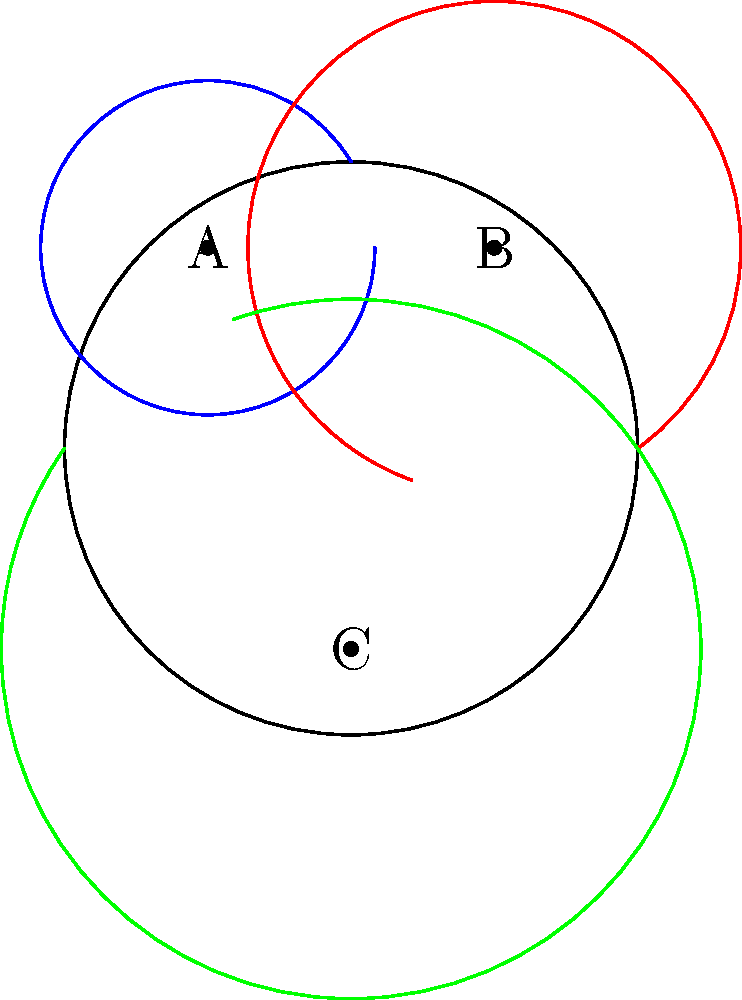On a non-Euclidean map of Greenland's municipalities represented by a sphere, three points A, B, and C represent the locations of Nuuk, Ilulissat, and Tasiilaq respectively. If the shortest path distance between Nuuk and Ilulissat (represented by the blue arc) is 800 km, and the distance between Ilulissat and Tasiilaq (represented by the red arc) is 1200 km, what is the approximate distance between Nuuk and Tasiilaq (represented by the green arc)? To solve this problem, we need to use spherical geometry principles:

1. First, we need to understand that on a sphere, the shortest path between two points is along a great circle, which is represented by the arcs in our diagram.

2. In spherical geometry, we use angular distances instead of linear distances. We need to convert our given distances to angles.

3. The full circumference of the Earth is approximately 40,000 km. This corresponds to 360°. So we can set up a proportion:

   40,000 km : 360° = 800 km : x°
   x = (800 * 360) / 40,000 = 7.2°

   Similarly, for the 1200 km arc:
   40,000 km : 360° = 1200 km : y°
   y = (1200 * 360) / 40,000 = 10.8°

4. Now we have a spherical triangle with two known side lengths (in degrees): 7.2° and 10.8°.

5. In a spherical triangle, the length of the third side is not simply the sum or difference of the other two sides. We need to use the spherical law of cosines:

   $$ \cos c = \cos a \cos b + \sin a \sin b \cos C $$

   Where $c$ is the side we're looking for, $a$ and $b$ are the known sides, and $C$ is the angle between them.

6. We don't know angle $C$, but we can estimate it from the diagram to be about 120°.

7. Plugging into the formula:

   $$ \cos c = \cos 7.2° \cos 10.8° + \sin 7.2° \sin 10.8° \cos 120° $$

8. Calculating this (you would use a calculator):

   $$ c \approx 15.7° $$

9. Converting back to kilometers:

   40,000 km : 360° = z km : 15.7°
   z = (15.7 * 40,000) / 360 ≈ 1744 km

Therefore, the approximate distance between Nuuk and Tasiilaq is 1744 km.
Answer: Approximately 1744 km 